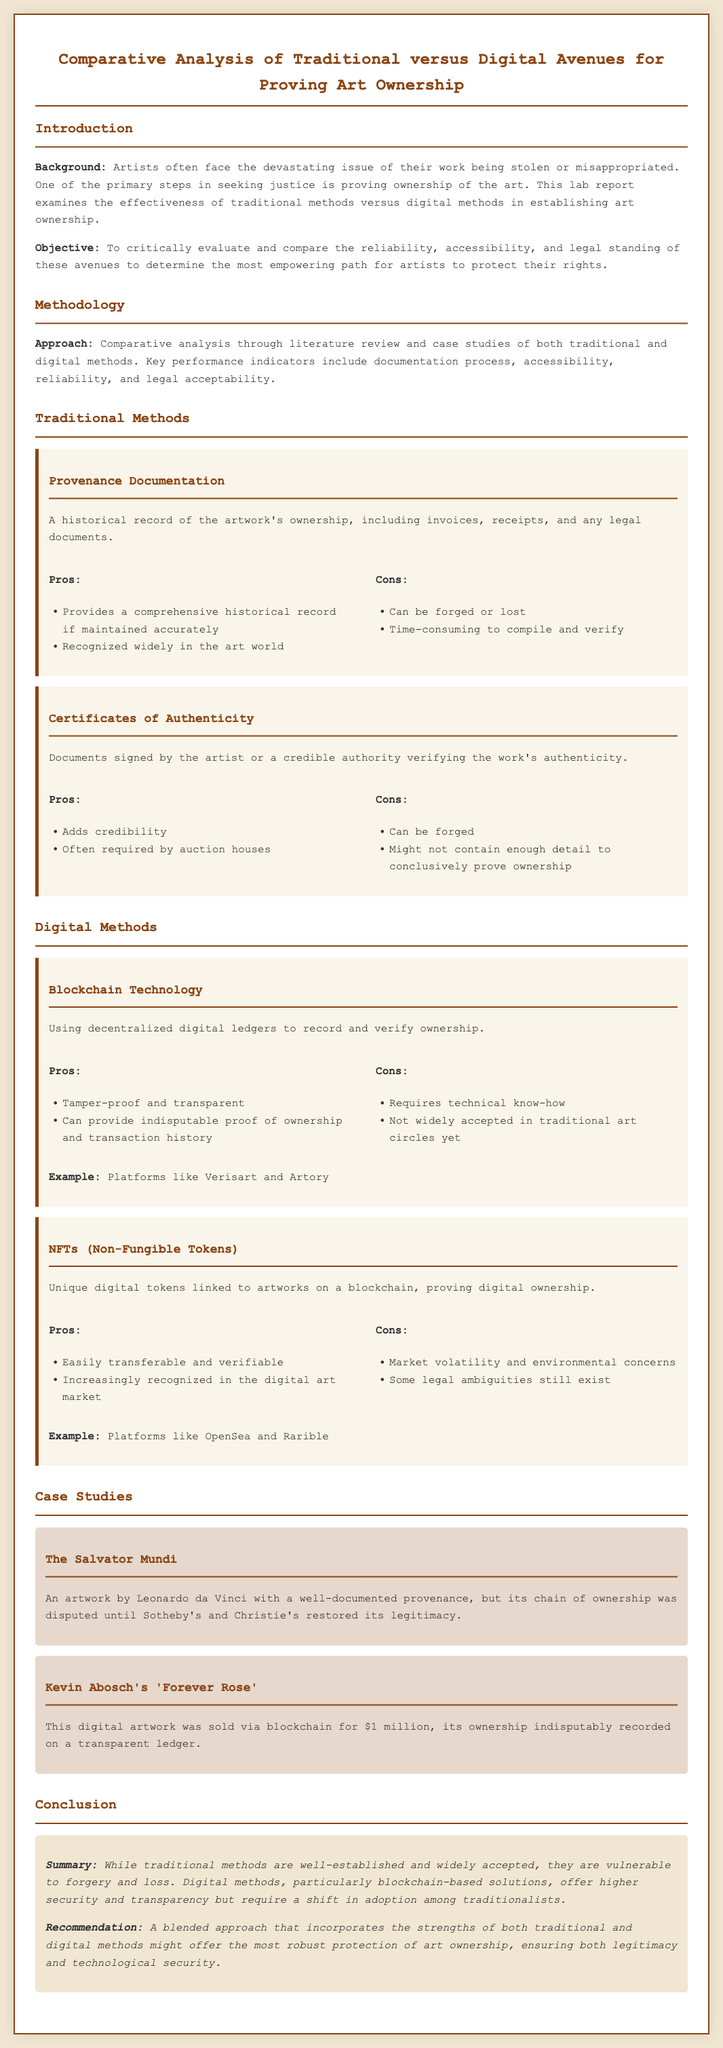what is the title of the report? The title of the report is prominently displayed at the beginning of the document.
Answer: Comparative Analysis of Traditional versus Digital Avenues for Proving Art Ownership what are the two main focuses of the report's objective? The report explicitly states its objectives related to the reliability and accessibility of the methods evaluated.
Answer: Reliability, accessibility which traditional method involves invoices and receipts? The document describes a specific traditional method that includes historical records like invoices and receipts.
Answer: Provenance Documentation what technology is mentioned as tamper-proof and transparent? The report lists a specific digital method known for its security features.
Answer: Blockchain Technology who is the artist associated with the 'Forever Rose'? The case study in the document identifies an artist related to a specific digital artwork.
Answer: Kevin Abosch what is the primary disadvantage of Certificates of Authenticity mentioned? The report discusses a common issue related to authenticity in traditional methods.
Answer: Can be forged which digital platform is mentioned for NFTs? The document provides examples of platforms where NFTs are commonly utilized.
Answer: OpenSea how does the report describe traditional methods of proving ownership? The report categorically portrays the nature of traditional methods, assessing their reliability.
Answer: Well-established and widely accepted what is recommended for art ownership protection? The conclusion in the report suggests a specific approach to enhance ownership legitimacy.
Answer: A blended approach 